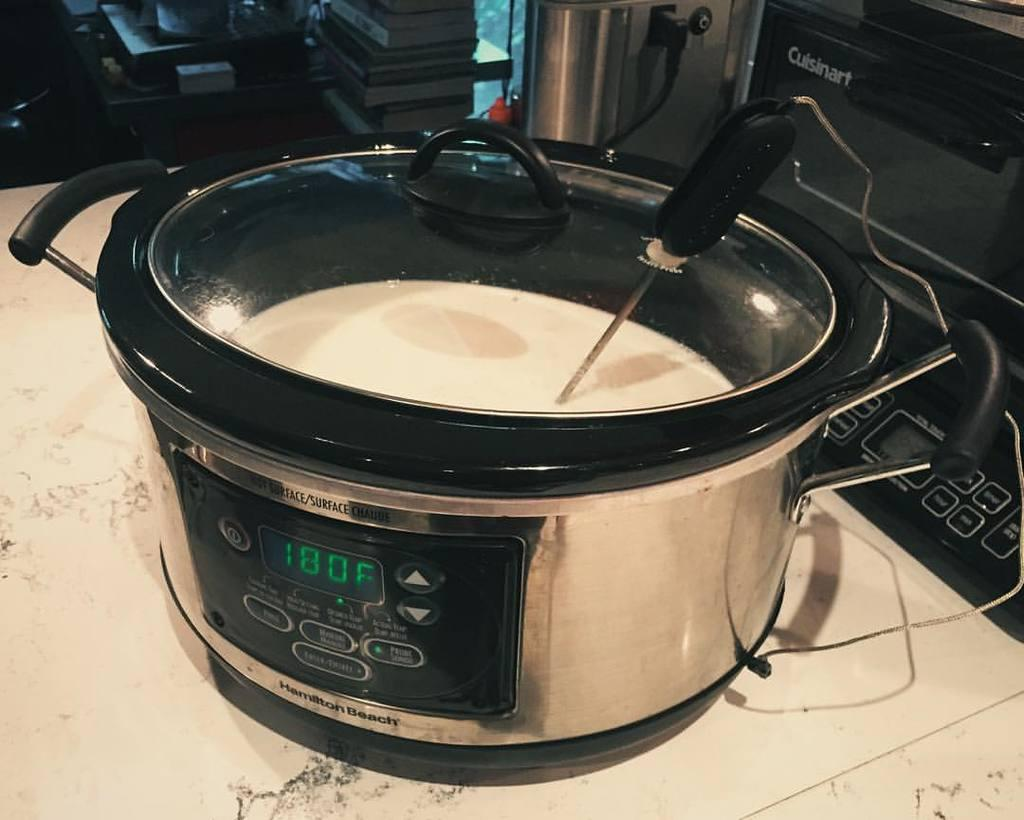<image>
Write a terse but informative summary of the picture. the cooker is set to 180 degrees F 